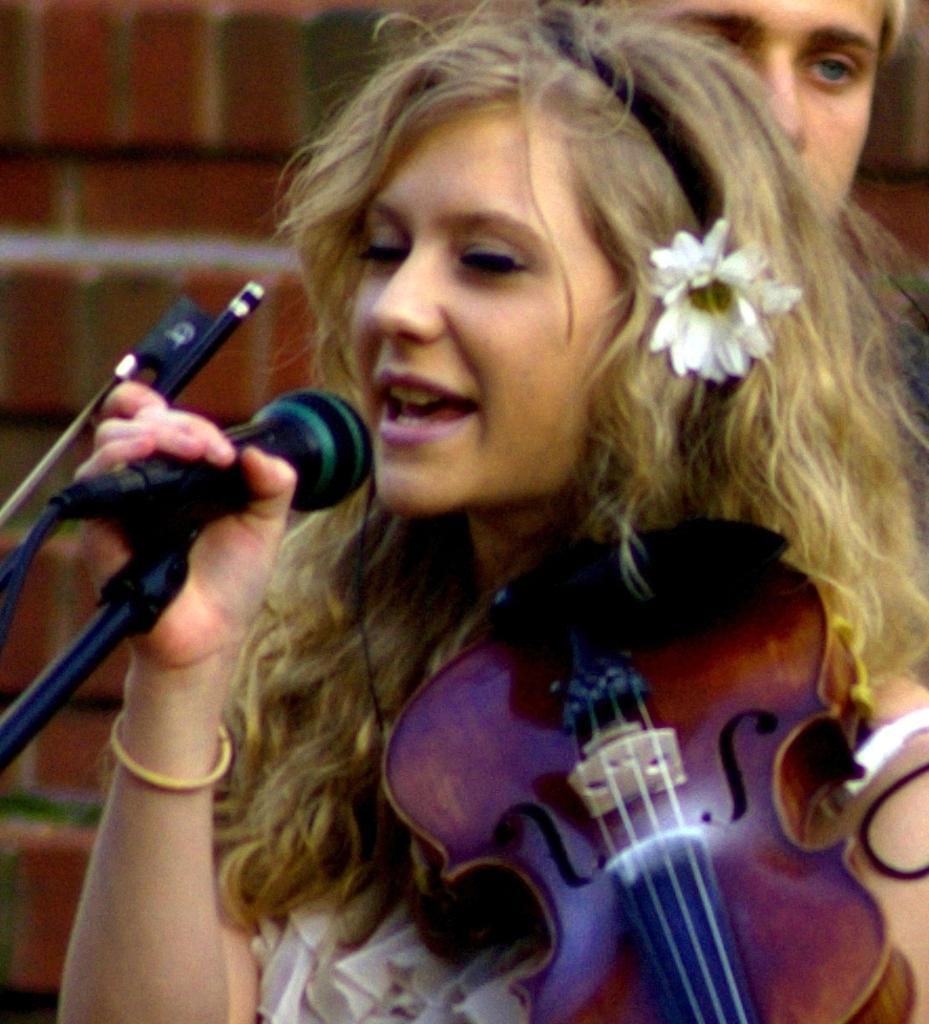How would you summarize this image in a sentence or two? This image consists of a woman who is holding a mic and singing something. She is also holding a musical instrument in her hand. There is a man behind her. 